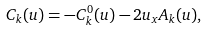Convert formula to latex. <formula><loc_0><loc_0><loc_500><loc_500>C _ { k } ( u ) = - C _ { k } ^ { 0 } ( u ) - 2 u _ { x } A _ { k } ( u ) ,</formula> 